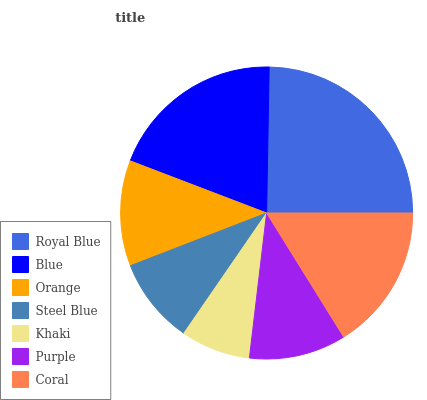Is Khaki the minimum?
Answer yes or no. Yes. Is Royal Blue the maximum?
Answer yes or no. Yes. Is Blue the minimum?
Answer yes or no. No. Is Blue the maximum?
Answer yes or no. No. Is Royal Blue greater than Blue?
Answer yes or no. Yes. Is Blue less than Royal Blue?
Answer yes or no. Yes. Is Blue greater than Royal Blue?
Answer yes or no. No. Is Royal Blue less than Blue?
Answer yes or no. No. Is Orange the high median?
Answer yes or no. Yes. Is Orange the low median?
Answer yes or no. Yes. Is Khaki the high median?
Answer yes or no. No. Is Steel Blue the low median?
Answer yes or no. No. 